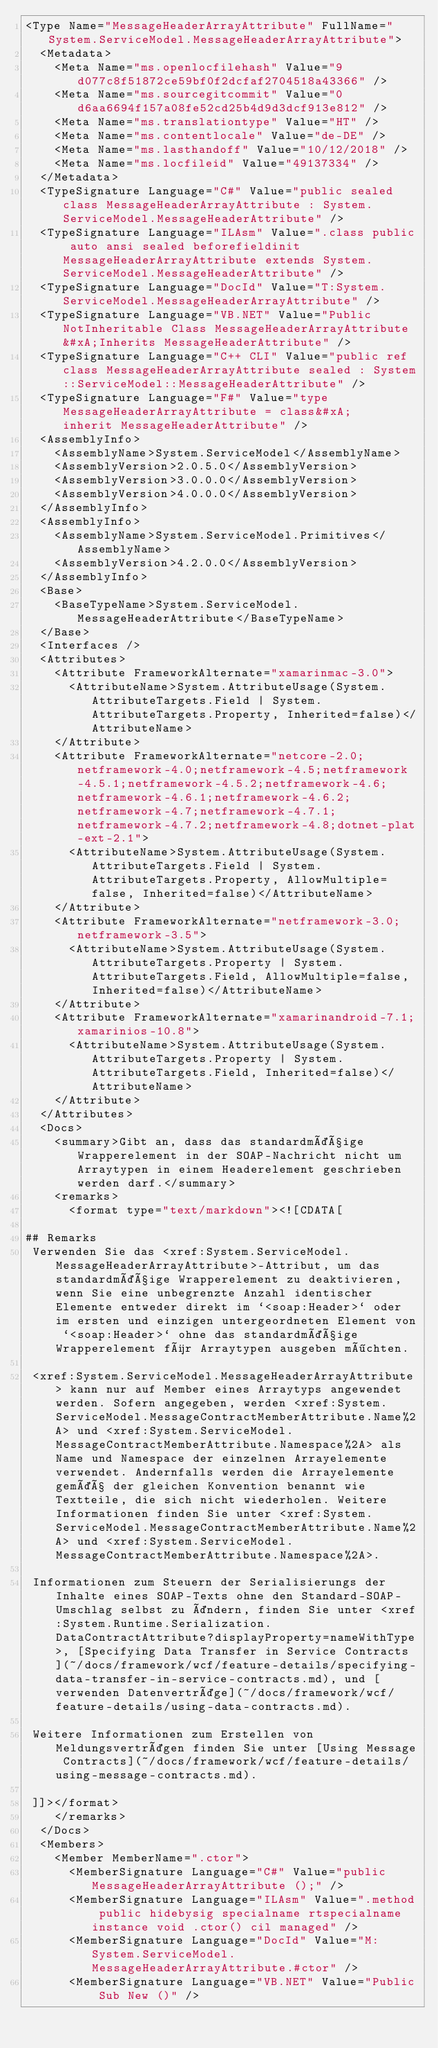<code> <loc_0><loc_0><loc_500><loc_500><_XML_><Type Name="MessageHeaderArrayAttribute" FullName="System.ServiceModel.MessageHeaderArrayAttribute">
  <Metadata>
    <Meta Name="ms.openlocfilehash" Value="9d077c8f51872ce59bf0f2dcfaf2704518a43366" />
    <Meta Name="ms.sourcegitcommit" Value="0d6aa6694f157a08fe52cd25b4d9d3dcf913e812" />
    <Meta Name="ms.translationtype" Value="HT" />
    <Meta Name="ms.contentlocale" Value="de-DE" />
    <Meta Name="ms.lasthandoff" Value="10/12/2018" />
    <Meta Name="ms.locfileid" Value="49137334" />
  </Metadata>
  <TypeSignature Language="C#" Value="public sealed class MessageHeaderArrayAttribute : System.ServiceModel.MessageHeaderAttribute" />
  <TypeSignature Language="ILAsm" Value=".class public auto ansi sealed beforefieldinit MessageHeaderArrayAttribute extends System.ServiceModel.MessageHeaderAttribute" />
  <TypeSignature Language="DocId" Value="T:System.ServiceModel.MessageHeaderArrayAttribute" />
  <TypeSignature Language="VB.NET" Value="Public NotInheritable Class MessageHeaderArrayAttribute&#xA;Inherits MessageHeaderAttribute" />
  <TypeSignature Language="C++ CLI" Value="public ref class MessageHeaderArrayAttribute sealed : System::ServiceModel::MessageHeaderAttribute" />
  <TypeSignature Language="F#" Value="type MessageHeaderArrayAttribute = class&#xA;    inherit MessageHeaderAttribute" />
  <AssemblyInfo>
    <AssemblyName>System.ServiceModel</AssemblyName>
    <AssemblyVersion>2.0.5.0</AssemblyVersion>
    <AssemblyVersion>3.0.0.0</AssemblyVersion>
    <AssemblyVersion>4.0.0.0</AssemblyVersion>
  </AssemblyInfo>
  <AssemblyInfo>
    <AssemblyName>System.ServiceModel.Primitives</AssemblyName>
    <AssemblyVersion>4.2.0.0</AssemblyVersion>
  </AssemblyInfo>
  <Base>
    <BaseTypeName>System.ServiceModel.MessageHeaderAttribute</BaseTypeName>
  </Base>
  <Interfaces />
  <Attributes>
    <Attribute FrameworkAlternate="xamarinmac-3.0">
      <AttributeName>System.AttributeUsage(System.AttributeTargets.Field | System.AttributeTargets.Property, Inherited=false)</AttributeName>
    </Attribute>
    <Attribute FrameworkAlternate="netcore-2.0;netframework-4.0;netframework-4.5;netframework-4.5.1;netframework-4.5.2;netframework-4.6;netframework-4.6.1;netframework-4.6.2;netframework-4.7;netframework-4.7.1;netframework-4.7.2;netframework-4.8;dotnet-plat-ext-2.1">
      <AttributeName>System.AttributeUsage(System.AttributeTargets.Field | System.AttributeTargets.Property, AllowMultiple=false, Inherited=false)</AttributeName>
    </Attribute>
    <Attribute FrameworkAlternate="netframework-3.0;netframework-3.5">
      <AttributeName>System.AttributeUsage(System.AttributeTargets.Property | System.AttributeTargets.Field, AllowMultiple=false, Inherited=false)</AttributeName>
    </Attribute>
    <Attribute FrameworkAlternate="xamarinandroid-7.1;xamarinios-10.8">
      <AttributeName>System.AttributeUsage(System.AttributeTargets.Property | System.AttributeTargets.Field, Inherited=false)</AttributeName>
    </Attribute>
  </Attributes>
  <Docs>
    <summary>Gibt an, dass das standardmäßige Wrapperelement in der SOAP-Nachricht nicht um Arraytypen in einem Headerelement geschrieben werden darf.</summary>
    <remarks>
      <format type="text/markdown"><![CDATA[  
  
## Remarks  
 Verwenden Sie das <xref:System.ServiceModel.MessageHeaderArrayAttribute>-Attribut, um das standardmäßige Wrapperelement zu deaktivieren, wenn Sie eine unbegrenzte Anzahl identischer Elemente entweder direkt im `<soap:Header>` oder im ersten und einzigen untergeordneten Element von `<soap:Header>` ohne das standardmäßige Wrapperelement für Arraytypen ausgeben möchten.  
  
 <xref:System.ServiceModel.MessageHeaderArrayAttribute> kann nur auf Member eines Arraytyps angewendet werden. Sofern angegeben, werden <xref:System.ServiceModel.MessageContractMemberAttribute.Name%2A> und <xref:System.ServiceModel.MessageContractMemberAttribute.Namespace%2A> als Name und Namespace der einzelnen Arrayelemente verwendet. Andernfalls werden die Arrayelemente gemäß der gleichen Konvention benannt wie Textteile, die sich nicht wiederholen. Weitere Informationen finden Sie unter <xref:System.ServiceModel.MessageContractMemberAttribute.Name%2A> und <xref:System.ServiceModel.MessageContractMemberAttribute.Namespace%2A>.  
  
 Informationen zum Steuern der Serialisierungs der Inhalte eines SOAP-Texts ohne den Standard-SOAP-Umschlag selbst zu ändern, finden Sie unter <xref:System.Runtime.Serialization.DataContractAttribute?displayProperty=nameWithType>, [Specifying Data Transfer in Service Contracts](~/docs/framework/wcf/feature-details/specifying-data-transfer-in-service-contracts.md), und [verwenden Datenverträge](~/docs/framework/wcf/feature-details/using-data-contracts.md).  
  
 Weitere Informationen zum Erstellen von Meldungsverträgen finden Sie unter [Using Message Contracts](~/docs/framework/wcf/feature-details/using-message-contracts.md).  
  
 ]]></format>
    </remarks>
  </Docs>
  <Members>
    <Member MemberName=".ctor">
      <MemberSignature Language="C#" Value="public MessageHeaderArrayAttribute ();" />
      <MemberSignature Language="ILAsm" Value=".method public hidebysig specialname rtspecialname instance void .ctor() cil managed" />
      <MemberSignature Language="DocId" Value="M:System.ServiceModel.MessageHeaderArrayAttribute.#ctor" />
      <MemberSignature Language="VB.NET" Value="Public Sub New ()" /></code> 